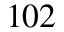Convert formula to latex. <formula><loc_0><loc_0><loc_500><loc_500>^ { 1 0 2 }</formula> 